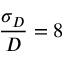Convert formula to latex. <formula><loc_0><loc_0><loc_500><loc_500>\frac { \sigma _ { D } } { D } = 8 \, \</formula> 